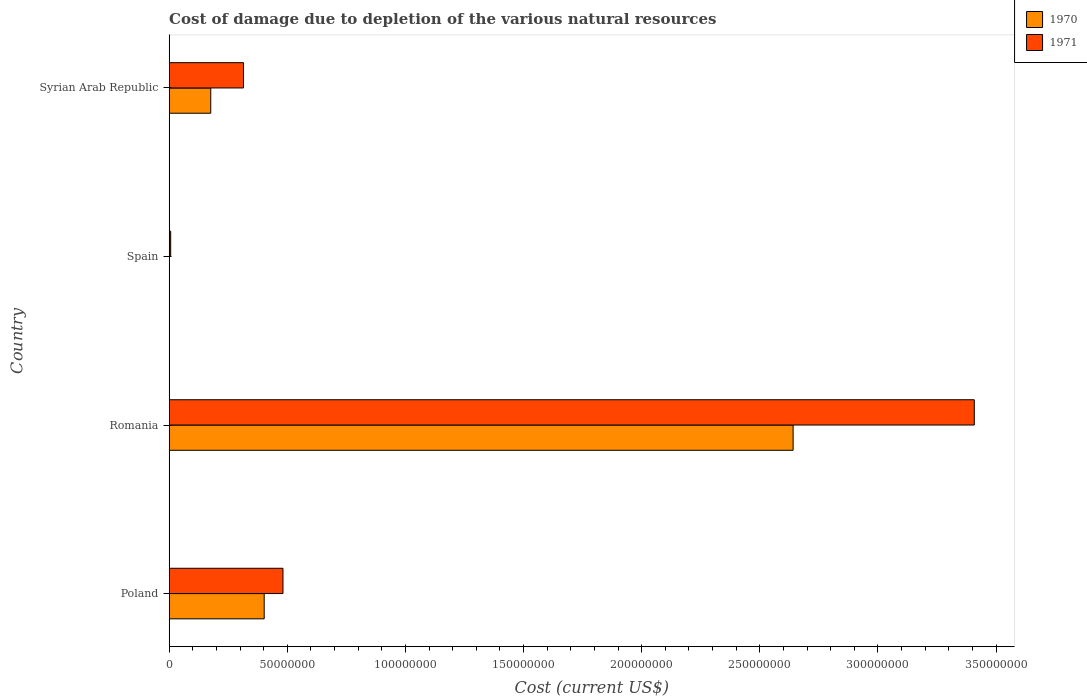How many groups of bars are there?
Your answer should be compact. 4. How many bars are there on the 3rd tick from the bottom?
Make the answer very short. 2. In how many cases, is the number of bars for a given country not equal to the number of legend labels?
Keep it short and to the point. 0. What is the cost of damage caused due to the depletion of various natural resources in 1971 in Syrian Arab Republic?
Your answer should be compact. 3.14e+07. Across all countries, what is the maximum cost of damage caused due to the depletion of various natural resources in 1970?
Your answer should be compact. 2.64e+08. Across all countries, what is the minimum cost of damage caused due to the depletion of various natural resources in 1971?
Offer a terse response. 6.25e+05. In which country was the cost of damage caused due to the depletion of various natural resources in 1971 maximum?
Your response must be concise. Romania. What is the total cost of damage caused due to the depletion of various natural resources in 1970 in the graph?
Provide a short and direct response. 3.22e+08. What is the difference between the cost of damage caused due to the depletion of various natural resources in 1970 in Romania and that in Syrian Arab Republic?
Your response must be concise. 2.47e+08. What is the difference between the cost of damage caused due to the depletion of various natural resources in 1970 in Poland and the cost of damage caused due to the depletion of various natural resources in 1971 in Spain?
Provide a short and direct response. 3.96e+07. What is the average cost of damage caused due to the depletion of various natural resources in 1971 per country?
Your answer should be very brief. 1.05e+08. What is the difference between the cost of damage caused due to the depletion of various natural resources in 1970 and cost of damage caused due to the depletion of various natural resources in 1971 in Spain?
Provide a succinct answer. -6.07e+05. In how many countries, is the cost of damage caused due to the depletion of various natural resources in 1970 greater than 10000000 US$?
Offer a very short reply. 3. What is the ratio of the cost of damage caused due to the depletion of various natural resources in 1970 in Spain to that in Syrian Arab Republic?
Provide a succinct answer. 0. Is the difference between the cost of damage caused due to the depletion of various natural resources in 1970 in Poland and Syrian Arab Republic greater than the difference between the cost of damage caused due to the depletion of various natural resources in 1971 in Poland and Syrian Arab Republic?
Offer a very short reply. Yes. What is the difference between the highest and the second highest cost of damage caused due to the depletion of various natural resources in 1970?
Your answer should be compact. 2.24e+08. What is the difference between the highest and the lowest cost of damage caused due to the depletion of various natural resources in 1971?
Provide a short and direct response. 3.40e+08. In how many countries, is the cost of damage caused due to the depletion of various natural resources in 1970 greater than the average cost of damage caused due to the depletion of various natural resources in 1970 taken over all countries?
Provide a short and direct response. 1. Is the sum of the cost of damage caused due to the depletion of various natural resources in 1971 in Poland and Romania greater than the maximum cost of damage caused due to the depletion of various natural resources in 1970 across all countries?
Your response must be concise. Yes. What does the 1st bar from the top in Syrian Arab Republic represents?
Offer a very short reply. 1971. What does the 1st bar from the bottom in Syrian Arab Republic represents?
Your answer should be very brief. 1970. How many bars are there?
Provide a succinct answer. 8. Are all the bars in the graph horizontal?
Keep it short and to the point. Yes. How many countries are there in the graph?
Your response must be concise. 4. What is the difference between two consecutive major ticks on the X-axis?
Ensure brevity in your answer.  5.00e+07. Are the values on the major ticks of X-axis written in scientific E-notation?
Make the answer very short. No. Where does the legend appear in the graph?
Ensure brevity in your answer.  Top right. How many legend labels are there?
Make the answer very short. 2. How are the legend labels stacked?
Your answer should be very brief. Vertical. What is the title of the graph?
Keep it short and to the point. Cost of damage due to depletion of the various natural resources. Does "1994" appear as one of the legend labels in the graph?
Make the answer very short. No. What is the label or title of the X-axis?
Make the answer very short. Cost (current US$). What is the Cost (current US$) of 1970 in Poland?
Ensure brevity in your answer.  4.02e+07. What is the Cost (current US$) of 1971 in Poland?
Offer a very short reply. 4.82e+07. What is the Cost (current US$) in 1970 in Romania?
Offer a very short reply. 2.64e+08. What is the Cost (current US$) of 1971 in Romania?
Your response must be concise. 3.41e+08. What is the Cost (current US$) of 1970 in Spain?
Your response must be concise. 1.78e+04. What is the Cost (current US$) of 1971 in Spain?
Keep it short and to the point. 6.25e+05. What is the Cost (current US$) in 1970 in Syrian Arab Republic?
Give a very brief answer. 1.76e+07. What is the Cost (current US$) of 1971 in Syrian Arab Republic?
Give a very brief answer. 3.14e+07. Across all countries, what is the maximum Cost (current US$) in 1970?
Provide a short and direct response. 2.64e+08. Across all countries, what is the maximum Cost (current US$) of 1971?
Offer a very short reply. 3.41e+08. Across all countries, what is the minimum Cost (current US$) in 1970?
Offer a terse response. 1.78e+04. Across all countries, what is the minimum Cost (current US$) of 1971?
Give a very brief answer. 6.25e+05. What is the total Cost (current US$) of 1970 in the graph?
Provide a short and direct response. 3.22e+08. What is the total Cost (current US$) in 1971 in the graph?
Keep it short and to the point. 4.21e+08. What is the difference between the Cost (current US$) in 1970 in Poland and that in Romania?
Offer a terse response. -2.24e+08. What is the difference between the Cost (current US$) in 1971 in Poland and that in Romania?
Provide a succinct answer. -2.93e+08. What is the difference between the Cost (current US$) in 1970 in Poland and that in Spain?
Make the answer very short. 4.02e+07. What is the difference between the Cost (current US$) in 1971 in Poland and that in Spain?
Offer a terse response. 4.75e+07. What is the difference between the Cost (current US$) in 1970 in Poland and that in Syrian Arab Republic?
Provide a succinct answer. 2.26e+07. What is the difference between the Cost (current US$) of 1971 in Poland and that in Syrian Arab Republic?
Offer a very short reply. 1.67e+07. What is the difference between the Cost (current US$) in 1970 in Romania and that in Spain?
Offer a terse response. 2.64e+08. What is the difference between the Cost (current US$) of 1971 in Romania and that in Spain?
Your response must be concise. 3.40e+08. What is the difference between the Cost (current US$) of 1970 in Romania and that in Syrian Arab Republic?
Offer a very short reply. 2.47e+08. What is the difference between the Cost (current US$) of 1971 in Romania and that in Syrian Arab Republic?
Provide a short and direct response. 3.09e+08. What is the difference between the Cost (current US$) in 1970 in Spain and that in Syrian Arab Republic?
Offer a terse response. -1.76e+07. What is the difference between the Cost (current US$) of 1971 in Spain and that in Syrian Arab Republic?
Offer a terse response. -3.08e+07. What is the difference between the Cost (current US$) of 1970 in Poland and the Cost (current US$) of 1971 in Romania?
Your answer should be very brief. -3.01e+08. What is the difference between the Cost (current US$) in 1970 in Poland and the Cost (current US$) in 1971 in Spain?
Ensure brevity in your answer.  3.96e+07. What is the difference between the Cost (current US$) of 1970 in Poland and the Cost (current US$) of 1971 in Syrian Arab Republic?
Provide a succinct answer. 8.75e+06. What is the difference between the Cost (current US$) of 1970 in Romania and the Cost (current US$) of 1971 in Spain?
Make the answer very short. 2.63e+08. What is the difference between the Cost (current US$) in 1970 in Romania and the Cost (current US$) in 1971 in Syrian Arab Republic?
Your answer should be very brief. 2.33e+08. What is the difference between the Cost (current US$) in 1970 in Spain and the Cost (current US$) in 1971 in Syrian Arab Republic?
Your response must be concise. -3.14e+07. What is the average Cost (current US$) in 1970 per country?
Give a very brief answer. 8.05e+07. What is the average Cost (current US$) in 1971 per country?
Your answer should be compact. 1.05e+08. What is the difference between the Cost (current US$) in 1970 and Cost (current US$) in 1971 in Poland?
Provide a short and direct response. -7.95e+06. What is the difference between the Cost (current US$) in 1970 and Cost (current US$) in 1971 in Romania?
Your response must be concise. -7.67e+07. What is the difference between the Cost (current US$) of 1970 and Cost (current US$) of 1971 in Spain?
Provide a succinct answer. -6.07e+05. What is the difference between the Cost (current US$) of 1970 and Cost (current US$) of 1971 in Syrian Arab Republic?
Provide a succinct answer. -1.39e+07. What is the ratio of the Cost (current US$) of 1970 in Poland to that in Romania?
Offer a terse response. 0.15. What is the ratio of the Cost (current US$) of 1971 in Poland to that in Romania?
Your response must be concise. 0.14. What is the ratio of the Cost (current US$) in 1970 in Poland to that in Spain?
Make the answer very short. 2259.53. What is the ratio of the Cost (current US$) of 1971 in Poland to that in Spain?
Offer a very short reply. 77.04. What is the ratio of the Cost (current US$) in 1970 in Poland to that in Syrian Arab Republic?
Provide a short and direct response. 2.29. What is the ratio of the Cost (current US$) in 1971 in Poland to that in Syrian Arab Republic?
Your answer should be very brief. 1.53. What is the ratio of the Cost (current US$) in 1970 in Romania to that in Spain?
Give a very brief answer. 1.48e+04. What is the ratio of the Cost (current US$) of 1971 in Romania to that in Spain?
Offer a terse response. 545.26. What is the ratio of the Cost (current US$) of 1970 in Romania to that in Syrian Arab Republic?
Offer a very short reply. 15.02. What is the ratio of the Cost (current US$) of 1971 in Romania to that in Syrian Arab Republic?
Offer a terse response. 10.84. What is the ratio of the Cost (current US$) in 1970 in Spain to that in Syrian Arab Republic?
Offer a very short reply. 0. What is the ratio of the Cost (current US$) of 1971 in Spain to that in Syrian Arab Republic?
Keep it short and to the point. 0.02. What is the difference between the highest and the second highest Cost (current US$) of 1970?
Make the answer very short. 2.24e+08. What is the difference between the highest and the second highest Cost (current US$) in 1971?
Offer a very short reply. 2.93e+08. What is the difference between the highest and the lowest Cost (current US$) of 1970?
Offer a very short reply. 2.64e+08. What is the difference between the highest and the lowest Cost (current US$) of 1971?
Offer a very short reply. 3.40e+08. 